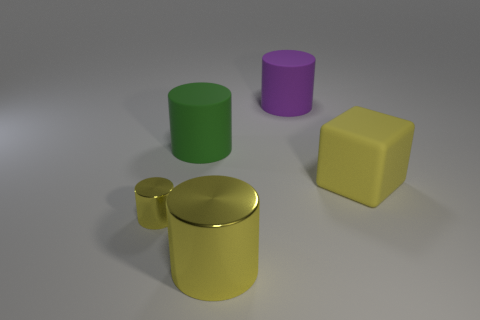Subtract all big yellow cylinders. How many cylinders are left? 3 Add 2 large gray shiny cylinders. How many objects exist? 7 Subtract all green cylinders. How many cylinders are left? 3 Add 2 green shiny cylinders. How many green shiny cylinders exist? 2 Subtract 0 gray cubes. How many objects are left? 5 Subtract all cubes. How many objects are left? 4 Subtract 1 cylinders. How many cylinders are left? 3 Subtract all red cylinders. Subtract all cyan balls. How many cylinders are left? 4 Subtract all cyan spheres. How many brown blocks are left? 0 Subtract all cylinders. Subtract all yellow rubber blocks. How many objects are left? 0 